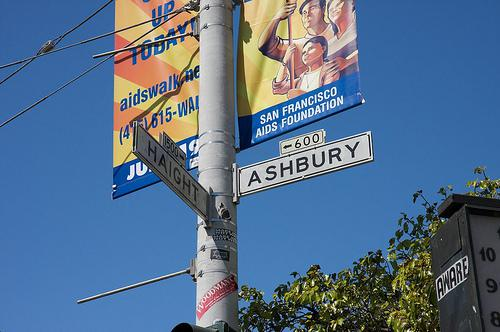Question: what is green in this picture?
Choices:
A. Grass.
B. Tree.
C. Bushes.
D. Plants.
Answer with the letter. Answer: B Question: how many street signs are there?
Choices:
A. 1.
B. 2.
C. 5.
D. 9.
Answer with the letter. Answer: B Question: how many numbers are shown on the clock?
Choices:
A. 12.
B. 3.
C. 10.
D. 4.
Answer with the letter. Answer: B 